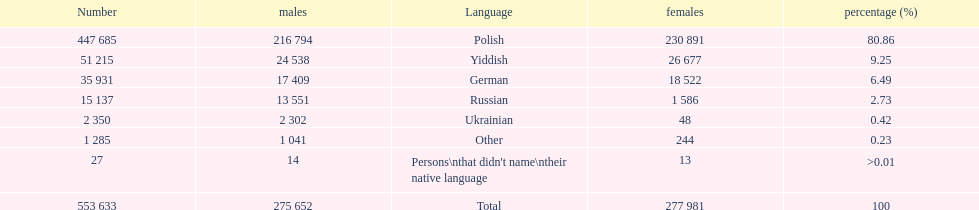How many people didn't name their native language? 27. 